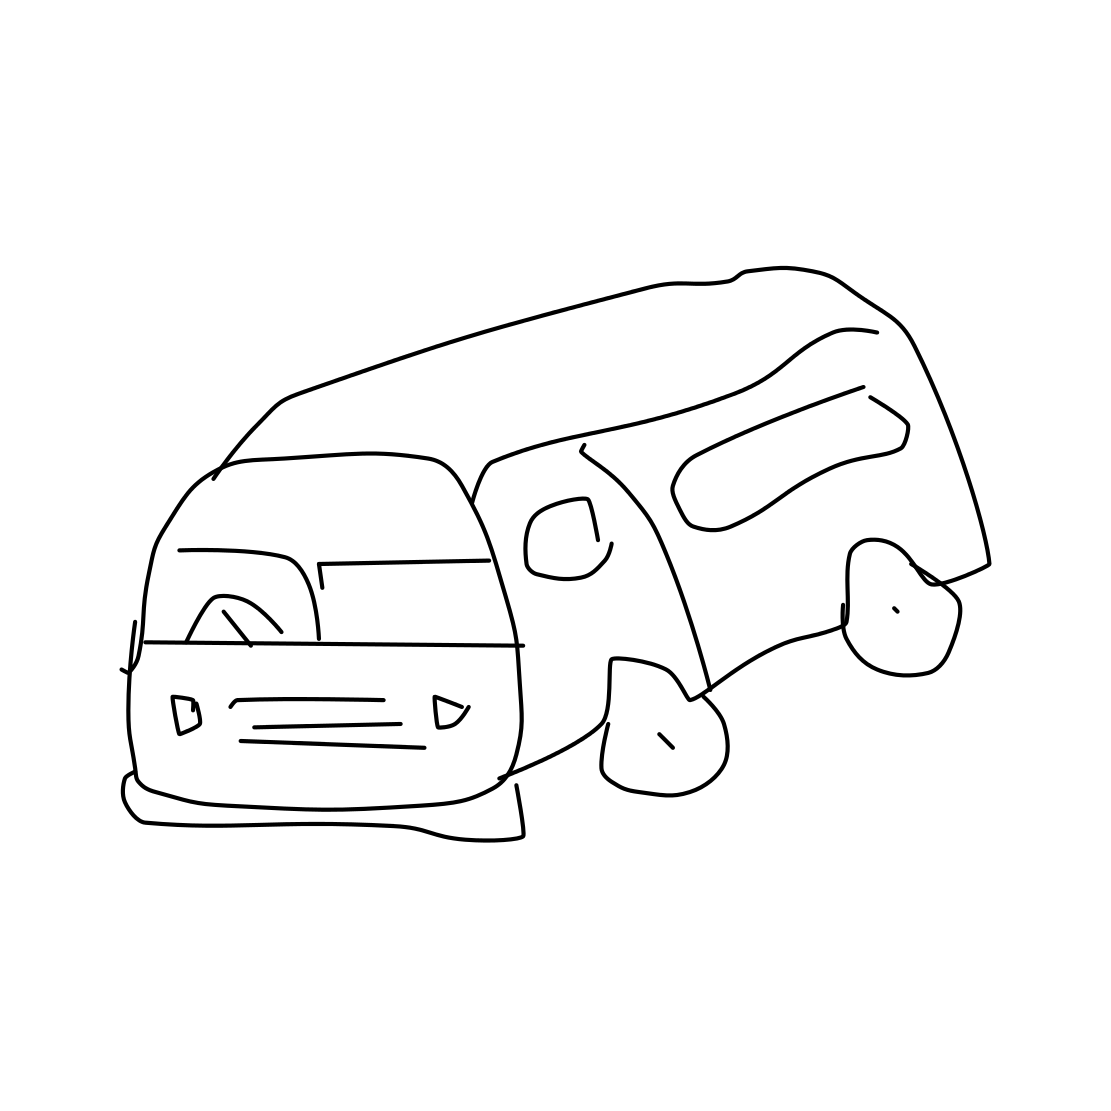Can you tell me more about the style of this drawing? The drawing appears to be a quick, freehand sketch, employing minimal lines and shapes to convey the form of a van. Its style is reminiscent of a doodle, where the essence of the subject is captured without intricate detailing. 